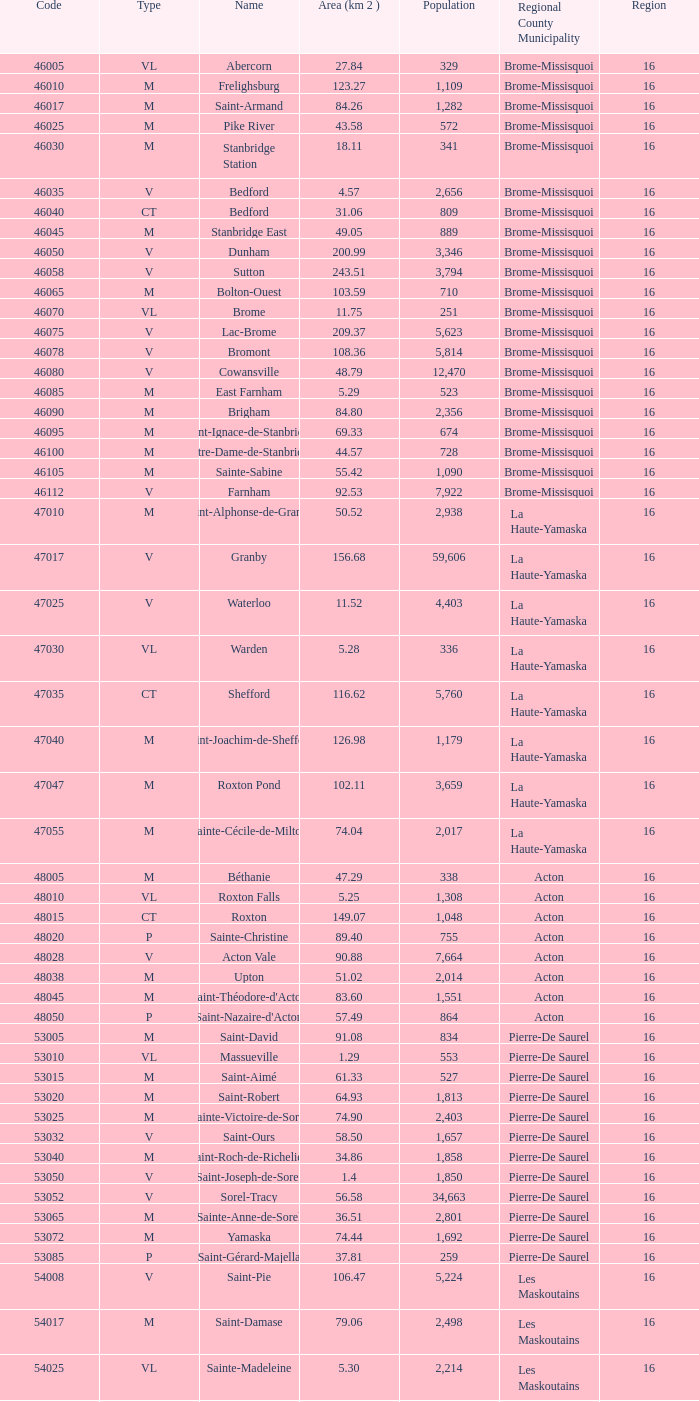In cowansville, a municipality in brome-missisquoi with less than 16 regions, what is the number of inhabitants? None. 